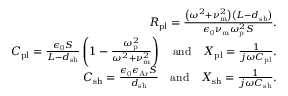Convert formula to latex. <formula><loc_0><loc_0><loc_500><loc_500>\begin{array} { r } { R _ { p l } = \frac { \left ( \omega ^ { 2 } + \nu _ { m } ^ { 2 } \right ) \left ( L - d _ { s h } \right ) } { \epsilon _ { 0 } \nu _ { m } \omega _ { p } ^ { 2 } S } . } \\ { C _ { p l } = \frac { \epsilon _ { 0 } S } { L - d _ { s h } } \left ( 1 - \frac { \omega _ { p } ^ { 2 } } { \omega ^ { 2 } + \nu _ { m } ^ { 2 } } \right ) \quad a n d \quad X _ { p l } = \frac { 1 } { j \omega C _ { p l } } . } \\ { C _ { s h } = \frac { \epsilon _ { 0 } \epsilon _ { A r } S } { d _ { s h } } \quad a n d \quad X _ { s h } = \frac { 1 } { j \omega C _ { s h } } . } \end{array}</formula> 